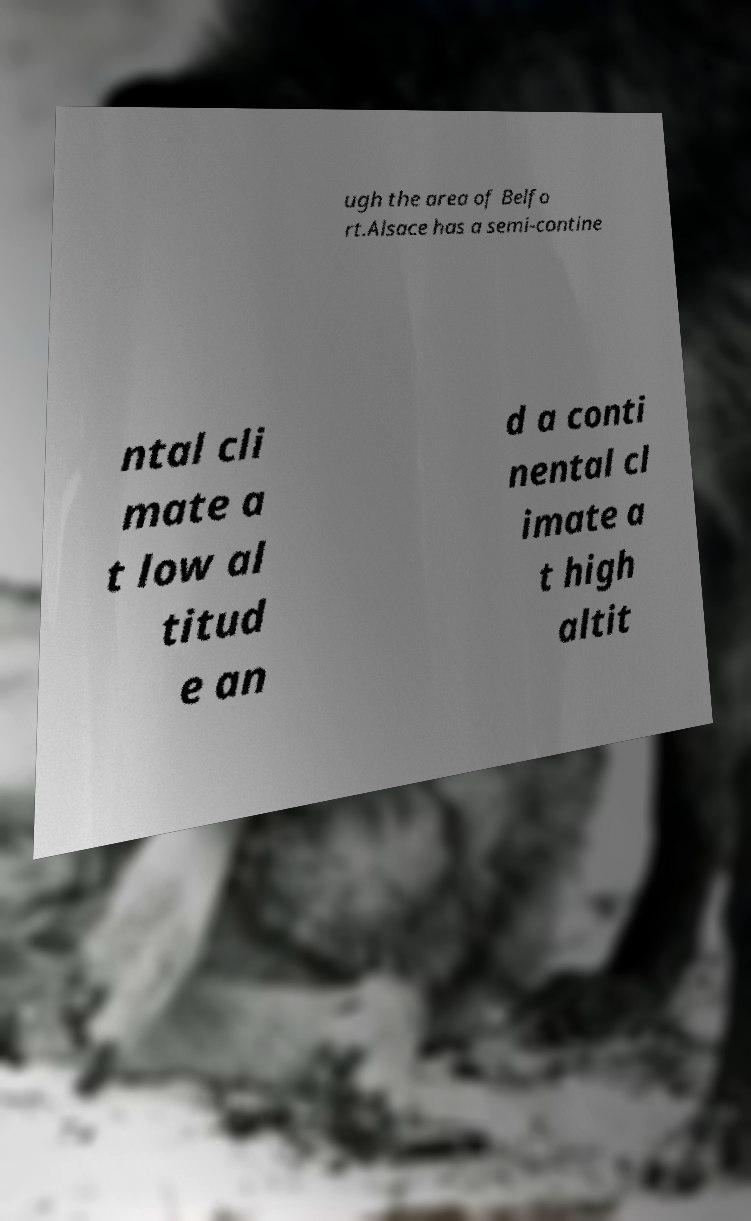Could you extract and type out the text from this image? ugh the area of Belfo rt.Alsace has a semi-contine ntal cli mate a t low al titud e an d a conti nental cl imate a t high altit 